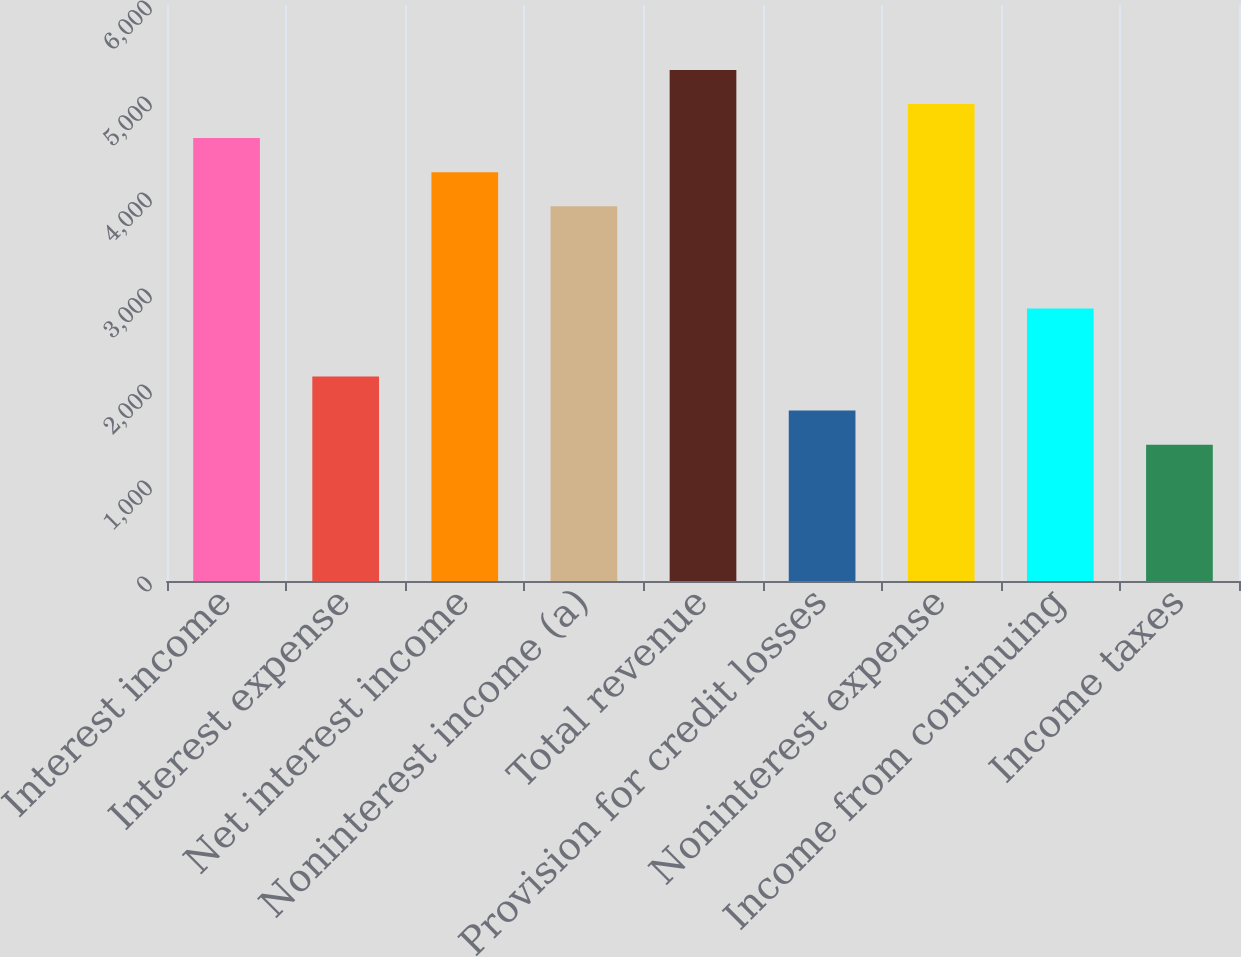<chart> <loc_0><loc_0><loc_500><loc_500><bar_chart><fcel>Interest income<fcel>Interest expense<fcel>Net interest income<fcel>Noninterest income (a)<fcel>Total revenue<fcel>Provision for credit losses<fcel>Noninterest expense<fcel>Income from continuing<fcel>Income taxes<nl><fcel>4613.39<fcel>2129.72<fcel>4258.58<fcel>3903.77<fcel>5323.01<fcel>1774.91<fcel>4968.2<fcel>2839.34<fcel>1420.1<nl></chart> 